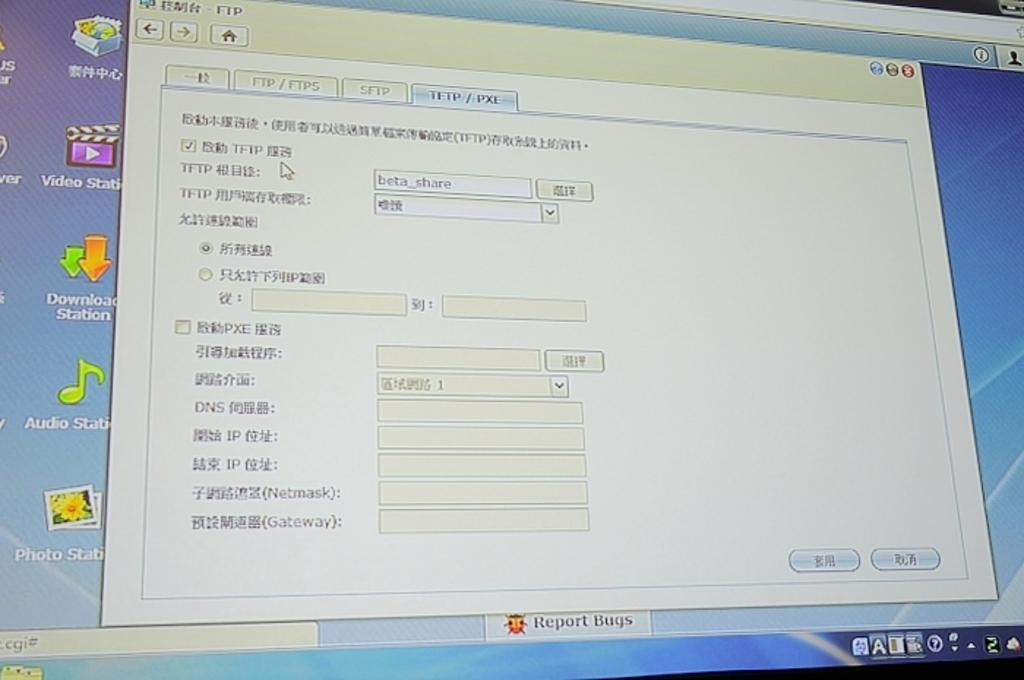<image>
Provide a brief description of the given image. A computer monitor has a screen open with foreign words on it and the Report Bugs tab under it. 